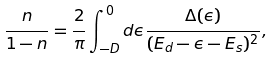Convert formula to latex. <formula><loc_0><loc_0><loc_500><loc_500>\frac { n } { 1 - n } = \frac { 2 } { \pi } \int _ { - D } ^ { 0 } d \epsilon \frac { \Delta ( \epsilon ) } { ( E _ { d } - \epsilon - E _ { s } ) ^ { 2 } } ,</formula> 